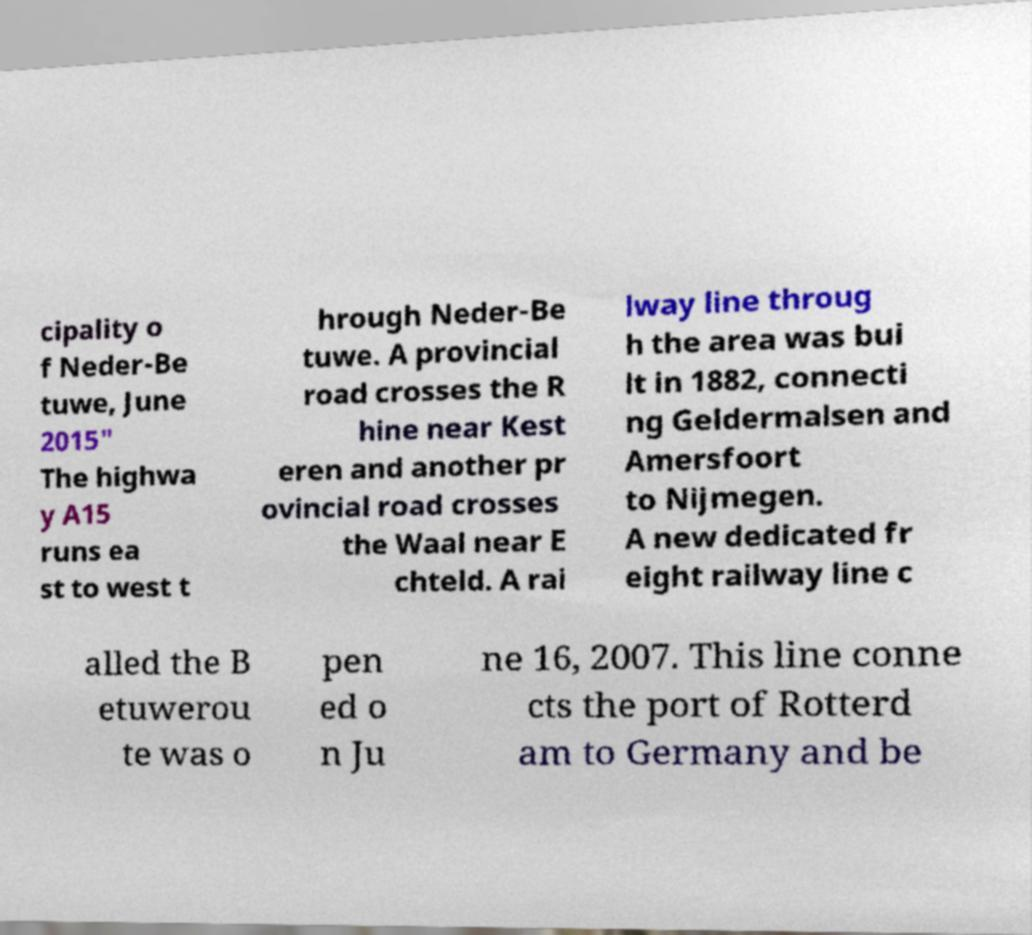For documentation purposes, I need the text within this image transcribed. Could you provide that? cipality o f Neder-Be tuwe, June 2015" The highwa y A15 runs ea st to west t hrough Neder-Be tuwe. A provincial road crosses the R hine near Kest eren and another pr ovincial road crosses the Waal near E chteld. A rai lway line throug h the area was bui lt in 1882, connecti ng Geldermalsen and Amersfoort to Nijmegen. A new dedicated fr eight railway line c alled the B etuwerou te was o pen ed o n Ju ne 16, 2007. This line conne cts the port of Rotterd am to Germany and be 